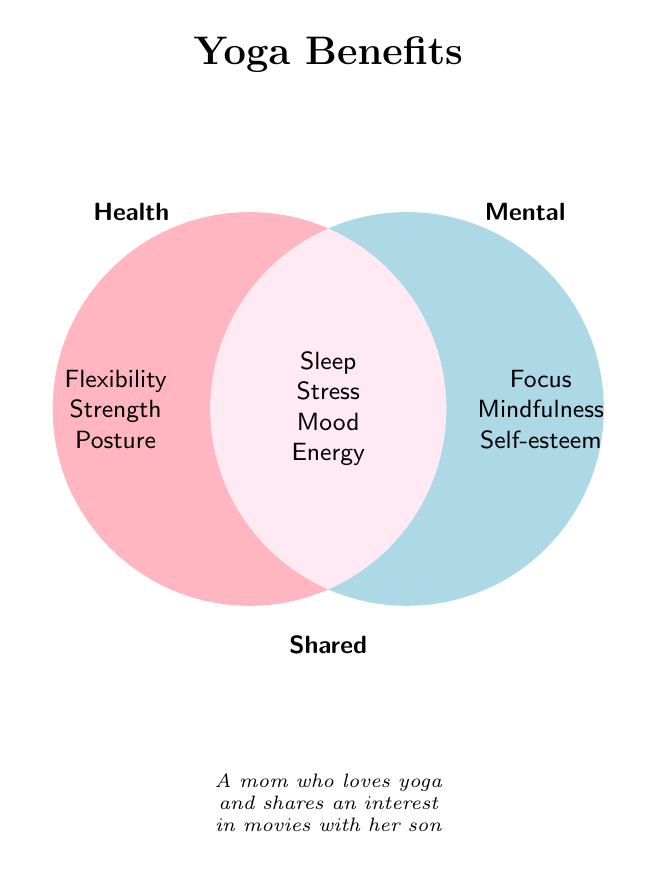What is the title of the figure? The title is typically in a larger font and positioned at the top of the figure. It clearly states the main topic.
Answer: Yoga Benefits Which category includes 'Enhanced posture'? Identify the section dedicated to health benefits in the Venn diagram and check the listed benefits.
Answer: Health Which listed benefit is shared by both health and mental categories? Look at the overlap region of the two circles where shared benefits are listed.
Answer: Sleep What color represents mental benefits? Observe the colored section of the Venn diagram labeled "Mental" to identify the color.
Answer: Light blue What are two health benefits of yoga not shared with mental benefits? Focus on the health-only section and note any of the benefits not in the shared section.
Answer: Flexibility, Strength Name one benefit that enhances mood. Look for the benefit listed under the shared section that mentions mood improvement.
Answer: Mood What is the relationship between stress and yoga practice according to the diagram? Examine which section lists 'Stress' and see it categorized under shared benefits.
Answer: Stress reduction How many shared benefits are listed in the figure? Count the number of benefits in the intersection of the Venn diagram.
Answer: Four Which category mentions 'Boosted self-esteem'? Check the mental benefits section for this specific benefit.
Answer: Mental Identify a mental benefit related to cognition improvement. Look for mental benefits that mention aspects of cognitive function.
Answer: Focus 